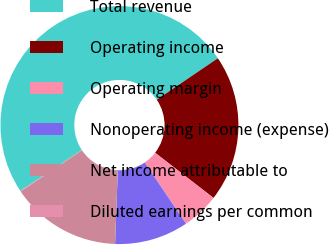Convert chart. <chart><loc_0><loc_0><loc_500><loc_500><pie_chart><fcel>Total revenue<fcel>Operating income<fcel>Operating margin<fcel>Nonoperating income (expense)<fcel>Net income attributable to<fcel>Diluted earnings per common<nl><fcel>49.83%<fcel>19.98%<fcel>5.06%<fcel>10.03%<fcel>15.01%<fcel>0.08%<nl></chart> 